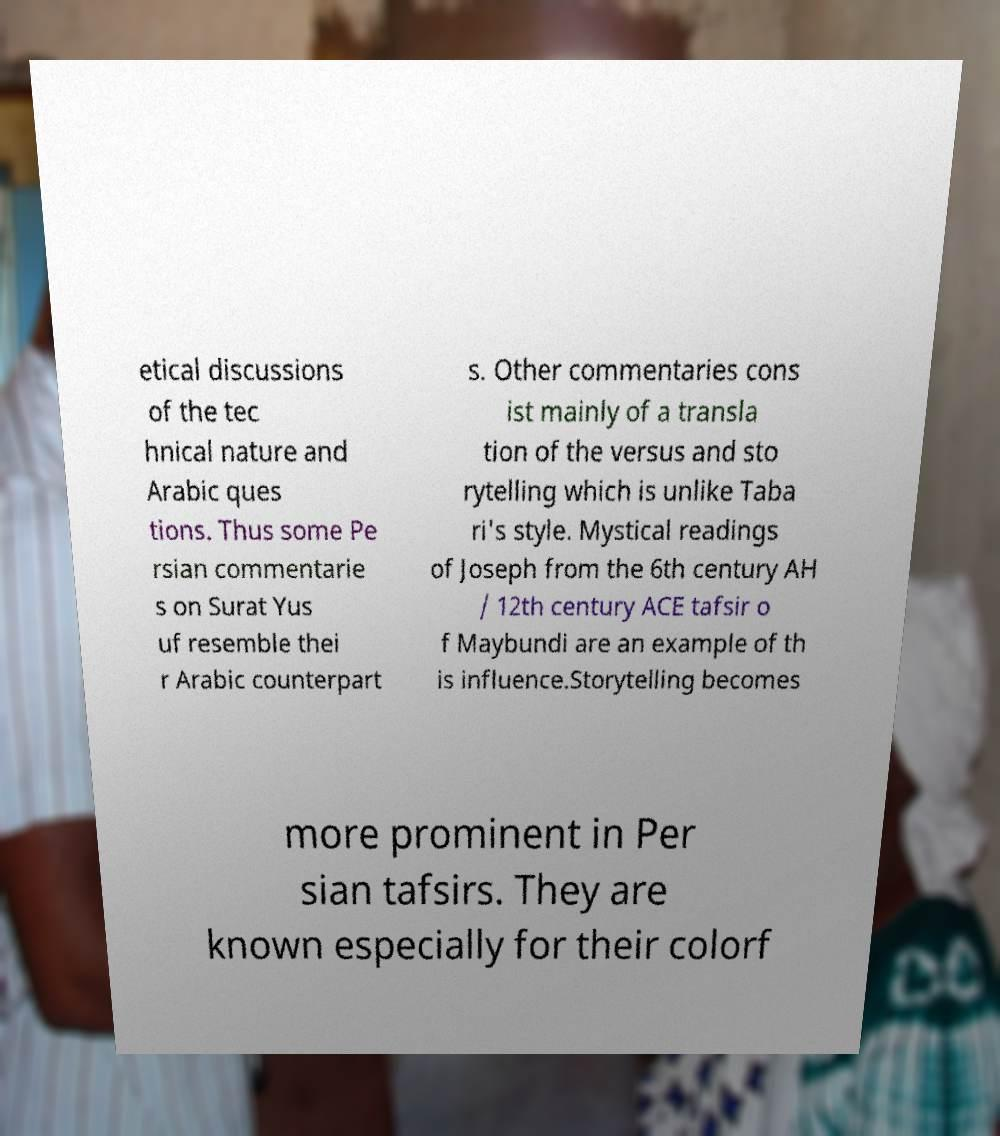What messages or text are displayed in this image? I need them in a readable, typed format. etical discussions of the tec hnical nature and Arabic ques tions. Thus some Pe rsian commentarie s on Surat Yus uf resemble thei r Arabic counterpart s. Other commentaries cons ist mainly of a transla tion of the versus and sto rytelling which is unlike Taba ri's style. Mystical readings of Joseph from the 6th century AH / 12th century ACE tafsir o f Maybundi are an example of th is influence.Storytelling becomes more prominent in Per sian tafsirs. They are known especially for their colorf 